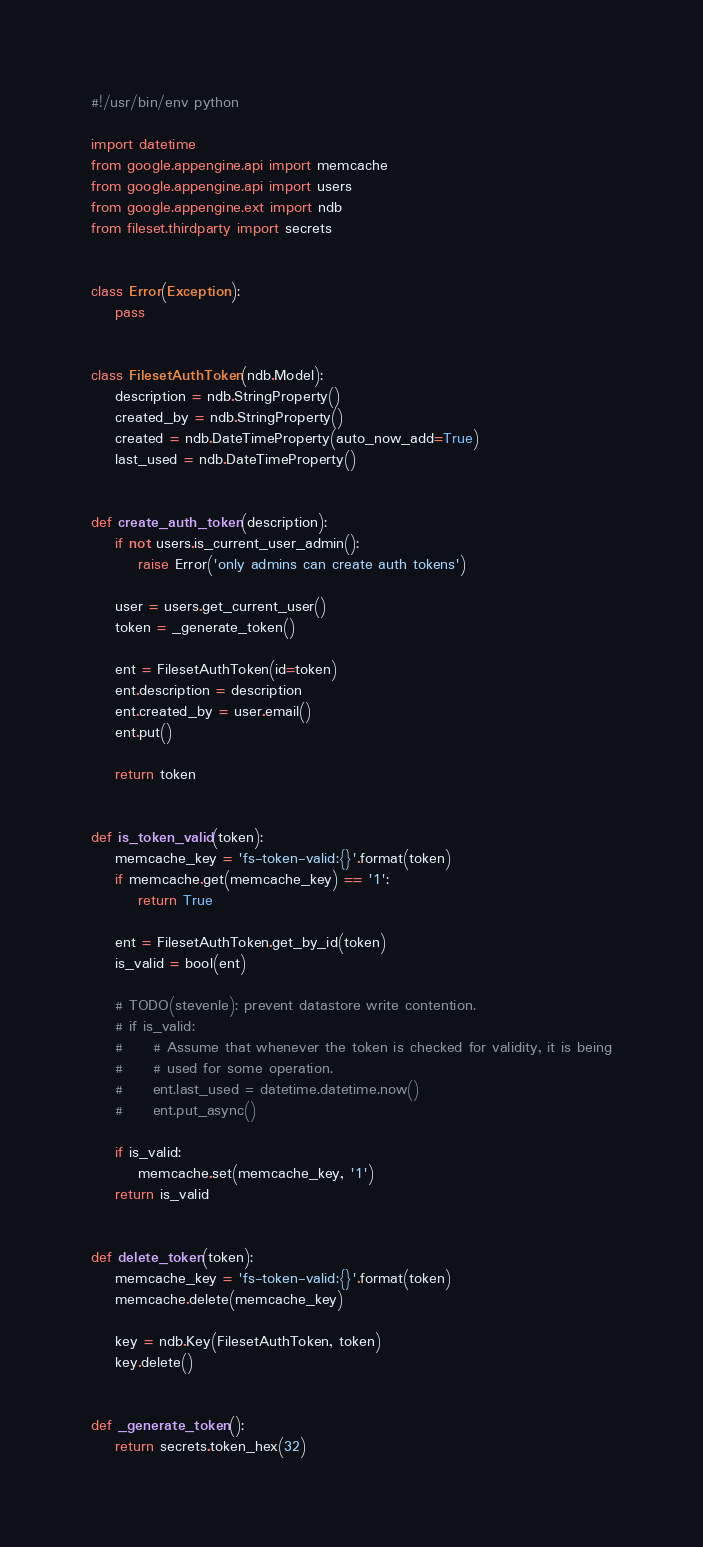<code> <loc_0><loc_0><loc_500><loc_500><_Python_>#!/usr/bin/env python

import datetime
from google.appengine.api import memcache
from google.appengine.api import users
from google.appengine.ext import ndb
from fileset.thirdparty import secrets


class Error(Exception):
    pass


class FilesetAuthToken(ndb.Model):
    description = ndb.StringProperty()
    created_by = ndb.StringProperty()
    created = ndb.DateTimeProperty(auto_now_add=True)
    last_used = ndb.DateTimeProperty()


def create_auth_token(description):
    if not users.is_current_user_admin():
        raise Error('only admins can create auth tokens')

    user = users.get_current_user()
    token = _generate_token()

    ent = FilesetAuthToken(id=token)
    ent.description = description
    ent.created_by = user.email()
    ent.put()

    return token


def is_token_valid(token):
    memcache_key = 'fs-token-valid:{}'.format(token)
    if memcache.get(memcache_key) == '1':
        return True

    ent = FilesetAuthToken.get_by_id(token)
    is_valid = bool(ent)

    # TODO(stevenle): prevent datastore write contention.
    # if is_valid:
    #     # Assume that whenever the token is checked for validity, it is being
    #     # used for some operation.
    #     ent.last_used = datetime.datetime.now()
    #     ent.put_async()

    if is_valid:
        memcache.set(memcache_key, '1')
    return is_valid


def delete_token(token):
    memcache_key = 'fs-token-valid:{}'.format(token)
    memcache.delete(memcache_key)

    key = ndb.Key(FilesetAuthToken, token)
    key.delete()


def _generate_token():
    return secrets.token_hex(32)
</code> 